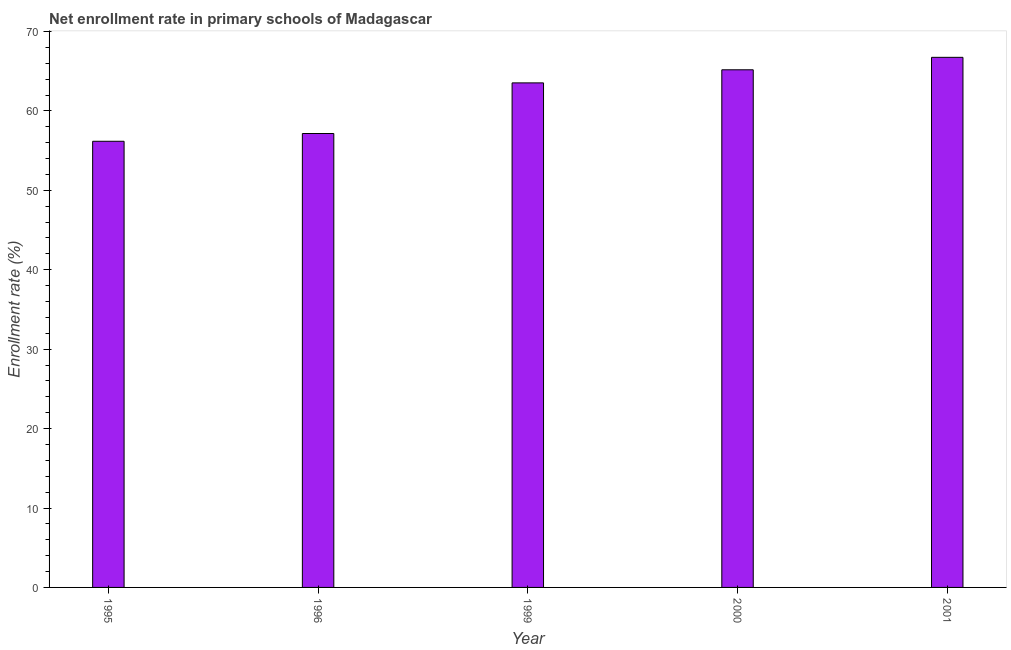Does the graph contain grids?
Provide a short and direct response. No. What is the title of the graph?
Offer a terse response. Net enrollment rate in primary schools of Madagascar. What is the label or title of the X-axis?
Provide a succinct answer. Year. What is the label or title of the Y-axis?
Your answer should be compact. Enrollment rate (%). What is the net enrollment rate in primary schools in 1995?
Provide a succinct answer. 56.18. Across all years, what is the maximum net enrollment rate in primary schools?
Give a very brief answer. 66.75. Across all years, what is the minimum net enrollment rate in primary schools?
Your answer should be very brief. 56.18. In which year was the net enrollment rate in primary schools minimum?
Offer a very short reply. 1995. What is the sum of the net enrollment rate in primary schools?
Provide a short and direct response. 308.8. What is the difference between the net enrollment rate in primary schools in 1995 and 1996?
Offer a terse response. -0.98. What is the average net enrollment rate in primary schools per year?
Make the answer very short. 61.76. What is the median net enrollment rate in primary schools?
Ensure brevity in your answer.  63.53. Is the net enrollment rate in primary schools in 1999 less than that in 2000?
Provide a succinct answer. Yes. What is the difference between the highest and the second highest net enrollment rate in primary schools?
Make the answer very short. 1.57. What is the difference between the highest and the lowest net enrollment rate in primary schools?
Keep it short and to the point. 10.57. How many bars are there?
Give a very brief answer. 5. Are the values on the major ticks of Y-axis written in scientific E-notation?
Your answer should be compact. No. What is the Enrollment rate (%) of 1995?
Provide a short and direct response. 56.18. What is the Enrollment rate (%) in 1996?
Ensure brevity in your answer.  57.16. What is the Enrollment rate (%) in 1999?
Offer a terse response. 63.53. What is the Enrollment rate (%) in 2000?
Provide a short and direct response. 65.18. What is the Enrollment rate (%) of 2001?
Keep it short and to the point. 66.75. What is the difference between the Enrollment rate (%) in 1995 and 1996?
Provide a short and direct response. -0.98. What is the difference between the Enrollment rate (%) in 1995 and 1999?
Your response must be concise. -7.35. What is the difference between the Enrollment rate (%) in 1995 and 2000?
Provide a succinct answer. -9. What is the difference between the Enrollment rate (%) in 1995 and 2001?
Make the answer very short. -10.57. What is the difference between the Enrollment rate (%) in 1996 and 1999?
Give a very brief answer. -6.37. What is the difference between the Enrollment rate (%) in 1996 and 2000?
Offer a very short reply. -8.02. What is the difference between the Enrollment rate (%) in 1996 and 2001?
Keep it short and to the point. -9.59. What is the difference between the Enrollment rate (%) in 1999 and 2000?
Keep it short and to the point. -1.65. What is the difference between the Enrollment rate (%) in 1999 and 2001?
Offer a very short reply. -3.22. What is the difference between the Enrollment rate (%) in 2000 and 2001?
Provide a succinct answer. -1.57. What is the ratio of the Enrollment rate (%) in 1995 to that in 1996?
Keep it short and to the point. 0.98. What is the ratio of the Enrollment rate (%) in 1995 to that in 1999?
Your response must be concise. 0.88. What is the ratio of the Enrollment rate (%) in 1995 to that in 2000?
Your response must be concise. 0.86. What is the ratio of the Enrollment rate (%) in 1995 to that in 2001?
Make the answer very short. 0.84. What is the ratio of the Enrollment rate (%) in 1996 to that in 1999?
Make the answer very short. 0.9. What is the ratio of the Enrollment rate (%) in 1996 to that in 2000?
Offer a very short reply. 0.88. What is the ratio of the Enrollment rate (%) in 1996 to that in 2001?
Your answer should be very brief. 0.86. What is the ratio of the Enrollment rate (%) in 1999 to that in 2000?
Your response must be concise. 0.97. 